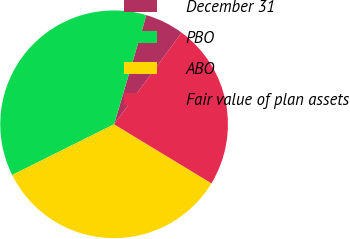<chart> <loc_0><loc_0><loc_500><loc_500><pie_chart><fcel>December 31<fcel>PBO<fcel>ABO<fcel>Fair value of plan assets<nl><fcel>5.53%<fcel>36.93%<fcel>33.97%<fcel>23.57%<nl></chart> 